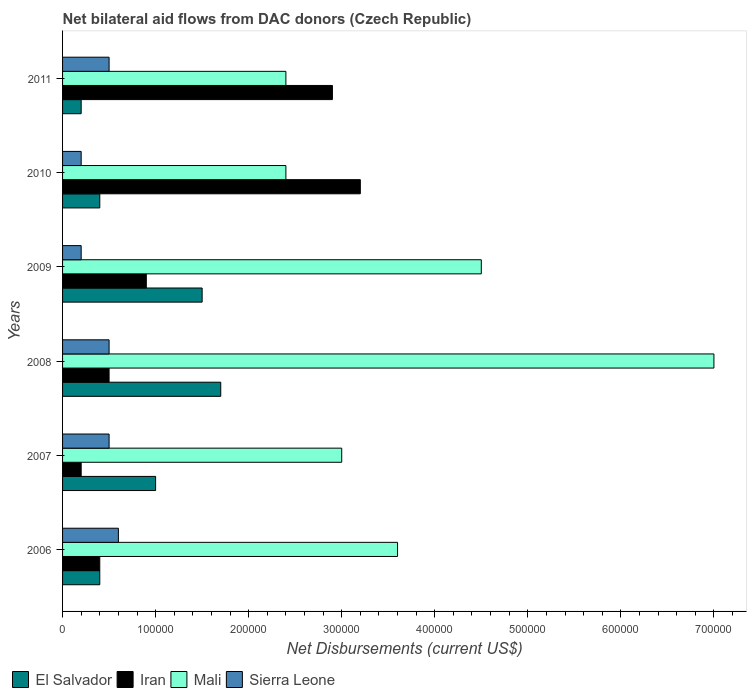How many different coloured bars are there?
Your answer should be compact. 4. How many groups of bars are there?
Offer a very short reply. 6. Are the number of bars on each tick of the Y-axis equal?
Keep it short and to the point. Yes. How many bars are there on the 4th tick from the bottom?
Make the answer very short. 4. What is the net bilateral aid flows in Iran in 2008?
Offer a terse response. 5.00e+04. Across all years, what is the maximum net bilateral aid flows in Mali?
Your response must be concise. 7.00e+05. Across all years, what is the minimum net bilateral aid flows in Iran?
Offer a terse response. 2.00e+04. In which year was the net bilateral aid flows in Iran minimum?
Ensure brevity in your answer.  2007. What is the total net bilateral aid flows in Sierra Leone in the graph?
Make the answer very short. 2.50e+05. What is the difference between the net bilateral aid flows in Sierra Leone in 2006 and that in 2007?
Ensure brevity in your answer.  10000. What is the difference between the net bilateral aid flows in El Salvador in 2006 and the net bilateral aid flows in Mali in 2008?
Make the answer very short. -6.60e+05. What is the average net bilateral aid flows in Mali per year?
Ensure brevity in your answer.  3.82e+05. In the year 2011, what is the difference between the net bilateral aid flows in El Salvador and net bilateral aid flows in Mali?
Give a very brief answer. -2.20e+05. In how many years, is the net bilateral aid flows in Sierra Leone greater than 540000 US$?
Your response must be concise. 0. What is the ratio of the net bilateral aid flows in Iran in 2010 to that in 2011?
Your response must be concise. 1.1. Is the net bilateral aid flows in Sierra Leone in 2006 less than that in 2011?
Keep it short and to the point. No. Is the difference between the net bilateral aid flows in El Salvador in 2006 and 2009 greater than the difference between the net bilateral aid flows in Mali in 2006 and 2009?
Your response must be concise. No. Is the sum of the net bilateral aid flows in El Salvador in 2009 and 2011 greater than the maximum net bilateral aid flows in Mali across all years?
Give a very brief answer. No. What does the 3rd bar from the top in 2009 represents?
Ensure brevity in your answer.  Iran. What does the 3rd bar from the bottom in 2011 represents?
Your answer should be very brief. Mali. How many years are there in the graph?
Your answer should be very brief. 6. What is the difference between two consecutive major ticks on the X-axis?
Offer a very short reply. 1.00e+05. Are the values on the major ticks of X-axis written in scientific E-notation?
Provide a short and direct response. No. Where does the legend appear in the graph?
Make the answer very short. Bottom left. How many legend labels are there?
Your response must be concise. 4. What is the title of the graph?
Ensure brevity in your answer.  Net bilateral aid flows from DAC donors (Czech Republic). What is the label or title of the X-axis?
Offer a terse response. Net Disbursements (current US$). What is the label or title of the Y-axis?
Your response must be concise. Years. What is the Net Disbursements (current US$) in El Salvador in 2007?
Offer a terse response. 1.00e+05. What is the Net Disbursements (current US$) of Iran in 2007?
Provide a succinct answer. 2.00e+04. What is the Net Disbursements (current US$) of Mali in 2007?
Your answer should be compact. 3.00e+05. What is the Net Disbursements (current US$) in Sierra Leone in 2007?
Your answer should be compact. 5.00e+04. What is the Net Disbursements (current US$) in Mali in 2008?
Offer a very short reply. 7.00e+05. What is the Net Disbursements (current US$) of Sierra Leone in 2008?
Make the answer very short. 5.00e+04. What is the Net Disbursements (current US$) of Iran in 2009?
Make the answer very short. 9.00e+04. What is the Net Disbursements (current US$) in Sierra Leone in 2009?
Provide a succinct answer. 2.00e+04. What is the Net Disbursements (current US$) of Mali in 2010?
Offer a terse response. 2.40e+05. What is the Net Disbursements (current US$) of Sierra Leone in 2010?
Provide a short and direct response. 2.00e+04. What is the Net Disbursements (current US$) in Mali in 2011?
Offer a terse response. 2.40e+05. Across all years, what is the maximum Net Disbursements (current US$) in El Salvador?
Ensure brevity in your answer.  1.70e+05. Across all years, what is the maximum Net Disbursements (current US$) in Iran?
Your answer should be very brief. 3.20e+05. Across all years, what is the maximum Net Disbursements (current US$) in Mali?
Keep it short and to the point. 7.00e+05. Across all years, what is the minimum Net Disbursements (current US$) of Iran?
Provide a succinct answer. 2.00e+04. Across all years, what is the minimum Net Disbursements (current US$) of Mali?
Offer a terse response. 2.40e+05. What is the total Net Disbursements (current US$) in El Salvador in the graph?
Offer a very short reply. 5.20e+05. What is the total Net Disbursements (current US$) of Iran in the graph?
Provide a short and direct response. 8.10e+05. What is the total Net Disbursements (current US$) in Mali in the graph?
Your answer should be compact. 2.29e+06. What is the total Net Disbursements (current US$) in Sierra Leone in the graph?
Keep it short and to the point. 2.50e+05. What is the difference between the Net Disbursements (current US$) in El Salvador in 2006 and that in 2007?
Make the answer very short. -6.00e+04. What is the difference between the Net Disbursements (current US$) of Iran in 2006 and that in 2007?
Your answer should be compact. 2.00e+04. What is the difference between the Net Disbursements (current US$) in El Salvador in 2006 and that in 2008?
Your answer should be compact. -1.30e+05. What is the difference between the Net Disbursements (current US$) of Iran in 2006 and that in 2008?
Make the answer very short. -10000. What is the difference between the Net Disbursements (current US$) in Mali in 2006 and that in 2009?
Give a very brief answer. -9.00e+04. What is the difference between the Net Disbursements (current US$) in Sierra Leone in 2006 and that in 2009?
Your answer should be very brief. 4.00e+04. What is the difference between the Net Disbursements (current US$) in El Salvador in 2006 and that in 2010?
Your response must be concise. 0. What is the difference between the Net Disbursements (current US$) in Iran in 2006 and that in 2010?
Your answer should be compact. -2.80e+05. What is the difference between the Net Disbursements (current US$) of Sierra Leone in 2006 and that in 2010?
Provide a succinct answer. 4.00e+04. What is the difference between the Net Disbursements (current US$) in Sierra Leone in 2006 and that in 2011?
Your answer should be compact. 10000. What is the difference between the Net Disbursements (current US$) of Iran in 2007 and that in 2008?
Ensure brevity in your answer.  -3.00e+04. What is the difference between the Net Disbursements (current US$) in Mali in 2007 and that in 2008?
Your answer should be compact. -4.00e+05. What is the difference between the Net Disbursements (current US$) of Iran in 2007 and that in 2009?
Keep it short and to the point. -7.00e+04. What is the difference between the Net Disbursements (current US$) of Mali in 2007 and that in 2011?
Your response must be concise. 6.00e+04. What is the difference between the Net Disbursements (current US$) in El Salvador in 2008 and that in 2009?
Provide a succinct answer. 2.00e+04. What is the difference between the Net Disbursements (current US$) in Iran in 2008 and that in 2009?
Your answer should be compact. -4.00e+04. What is the difference between the Net Disbursements (current US$) of Mali in 2008 and that in 2009?
Provide a short and direct response. 2.50e+05. What is the difference between the Net Disbursements (current US$) in El Salvador in 2008 and that in 2010?
Your response must be concise. 1.30e+05. What is the difference between the Net Disbursements (current US$) of Sierra Leone in 2008 and that in 2010?
Ensure brevity in your answer.  3.00e+04. What is the difference between the Net Disbursements (current US$) in Mali in 2008 and that in 2011?
Make the answer very short. 4.60e+05. What is the difference between the Net Disbursements (current US$) of Mali in 2009 and that in 2010?
Ensure brevity in your answer.  2.10e+05. What is the difference between the Net Disbursements (current US$) of Sierra Leone in 2009 and that in 2010?
Ensure brevity in your answer.  0. What is the difference between the Net Disbursements (current US$) in El Salvador in 2009 and that in 2011?
Provide a succinct answer. 1.30e+05. What is the difference between the Net Disbursements (current US$) of Iran in 2009 and that in 2011?
Ensure brevity in your answer.  -2.00e+05. What is the difference between the Net Disbursements (current US$) in El Salvador in 2010 and that in 2011?
Provide a succinct answer. 2.00e+04. What is the difference between the Net Disbursements (current US$) in Mali in 2010 and that in 2011?
Provide a short and direct response. 0. What is the difference between the Net Disbursements (current US$) in El Salvador in 2006 and the Net Disbursements (current US$) in Iran in 2007?
Your answer should be compact. 2.00e+04. What is the difference between the Net Disbursements (current US$) in Iran in 2006 and the Net Disbursements (current US$) in Mali in 2007?
Offer a terse response. -2.60e+05. What is the difference between the Net Disbursements (current US$) of Iran in 2006 and the Net Disbursements (current US$) of Sierra Leone in 2007?
Keep it short and to the point. -10000. What is the difference between the Net Disbursements (current US$) in El Salvador in 2006 and the Net Disbursements (current US$) in Mali in 2008?
Provide a succinct answer. -6.60e+05. What is the difference between the Net Disbursements (current US$) of El Salvador in 2006 and the Net Disbursements (current US$) of Sierra Leone in 2008?
Offer a very short reply. -10000. What is the difference between the Net Disbursements (current US$) of Iran in 2006 and the Net Disbursements (current US$) of Mali in 2008?
Keep it short and to the point. -6.60e+05. What is the difference between the Net Disbursements (current US$) of El Salvador in 2006 and the Net Disbursements (current US$) of Iran in 2009?
Provide a short and direct response. -5.00e+04. What is the difference between the Net Disbursements (current US$) of El Salvador in 2006 and the Net Disbursements (current US$) of Mali in 2009?
Provide a short and direct response. -4.10e+05. What is the difference between the Net Disbursements (current US$) in El Salvador in 2006 and the Net Disbursements (current US$) in Sierra Leone in 2009?
Your response must be concise. 2.00e+04. What is the difference between the Net Disbursements (current US$) in Iran in 2006 and the Net Disbursements (current US$) in Mali in 2009?
Provide a short and direct response. -4.10e+05. What is the difference between the Net Disbursements (current US$) of Mali in 2006 and the Net Disbursements (current US$) of Sierra Leone in 2009?
Your response must be concise. 3.40e+05. What is the difference between the Net Disbursements (current US$) in El Salvador in 2006 and the Net Disbursements (current US$) in Iran in 2010?
Ensure brevity in your answer.  -2.80e+05. What is the difference between the Net Disbursements (current US$) of El Salvador in 2006 and the Net Disbursements (current US$) of Sierra Leone in 2010?
Your response must be concise. 2.00e+04. What is the difference between the Net Disbursements (current US$) of Iran in 2006 and the Net Disbursements (current US$) of Sierra Leone in 2010?
Ensure brevity in your answer.  2.00e+04. What is the difference between the Net Disbursements (current US$) of El Salvador in 2006 and the Net Disbursements (current US$) of Mali in 2011?
Keep it short and to the point. -2.00e+05. What is the difference between the Net Disbursements (current US$) of Iran in 2006 and the Net Disbursements (current US$) of Mali in 2011?
Ensure brevity in your answer.  -2.00e+05. What is the difference between the Net Disbursements (current US$) in Iran in 2006 and the Net Disbursements (current US$) in Sierra Leone in 2011?
Ensure brevity in your answer.  -10000. What is the difference between the Net Disbursements (current US$) in Mali in 2006 and the Net Disbursements (current US$) in Sierra Leone in 2011?
Your response must be concise. 3.10e+05. What is the difference between the Net Disbursements (current US$) of El Salvador in 2007 and the Net Disbursements (current US$) of Mali in 2008?
Provide a short and direct response. -6.00e+05. What is the difference between the Net Disbursements (current US$) of Iran in 2007 and the Net Disbursements (current US$) of Mali in 2008?
Make the answer very short. -6.80e+05. What is the difference between the Net Disbursements (current US$) of Mali in 2007 and the Net Disbursements (current US$) of Sierra Leone in 2008?
Your response must be concise. 2.50e+05. What is the difference between the Net Disbursements (current US$) in El Salvador in 2007 and the Net Disbursements (current US$) in Iran in 2009?
Your answer should be very brief. 10000. What is the difference between the Net Disbursements (current US$) in El Salvador in 2007 and the Net Disbursements (current US$) in Mali in 2009?
Give a very brief answer. -3.50e+05. What is the difference between the Net Disbursements (current US$) in El Salvador in 2007 and the Net Disbursements (current US$) in Sierra Leone in 2009?
Your answer should be compact. 8.00e+04. What is the difference between the Net Disbursements (current US$) of Iran in 2007 and the Net Disbursements (current US$) of Mali in 2009?
Your answer should be compact. -4.30e+05. What is the difference between the Net Disbursements (current US$) of Mali in 2007 and the Net Disbursements (current US$) of Sierra Leone in 2009?
Provide a short and direct response. 2.80e+05. What is the difference between the Net Disbursements (current US$) of El Salvador in 2007 and the Net Disbursements (current US$) of Iran in 2011?
Offer a very short reply. -1.90e+05. What is the difference between the Net Disbursements (current US$) of El Salvador in 2007 and the Net Disbursements (current US$) of Mali in 2011?
Provide a short and direct response. -1.40e+05. What is the difference between the Net Disbursements (current US$) in Iran in 2007 and the Net Disbursements (current US$) in Mali in 2011?
Offer a terse response. -2.20e+05. What is the difference between the Net Disbursements (current US$) in Iran in 2007 and the Net Disbursements (current US$) in Sierra Leone in 2011?
Offer a very short reply. -3.00e+04. What is the difference between the Net Disbursements (current US$) in Mali in 2007 and the Net Disbursements (current US$) in Sierra Leone in 2011?
Give a very brief answer. 2.50e+05. What is the difference between the Net Disbursements (current US$) of El Salvador in 2008 and the Net Disbursements (current US$) of Mali in 2009?
Keep it short and to the point. -2.80e+05. What is the difference between the Net Disbursements (current US$) in Iran in 2008 and the Net Disbursements (current US$) in Mali in 2009?
Make the answer very short. -4.00e+05. What is the difference between the Net Disbursements (current US$) in Mali in 2008 and the Net Disbursements (current US$) in Sierra Leone in 2009?
Offer a very short reply. 6.80e+05. What is the difference between the Net Disbursements (current US$) in El Salvador in 2008 and the Net Disbursements (current US$) in Iran in 2010?
Offer a terse response. -1.50e+05. What is the difference between the Net Disbursements (current US$) of El Salvador in 2008 and the Net Disbursements (current US$) of Sierra Leone in 2010?
Your response must be concise. 1.50e+05. What is the difference between the Net Disbursements (current US$) in Iran in 2008 and the Net Disbursements (current US$) in Mali in 2010?
Your answer should be compact. -1.90e+05. What is the difference between the Net Disbursements (current US$) of Iran in 2008 and the Net Disbursements (current US$) of Sierra Leone in 2010?
Give a very brief answer. 3.00e+04. What is the difference between the Net Disbursements (current US$) of Mali in 2008 and the Net Disbursements (current US$) of Sierra Leone in 2010?
Your answer should be very brief. 6.80e+05. What is the difference between the Net Disbursements (current US$) of El Salvador in 2008 and the Net Disbursements (current US$) of Mali in 2011?
Ensure brevity in your answer.  -7.00e+04. What is the difference between the Net Disbursements (current US$) in El Salvador in 2008 and the Net Disbursements (current US$) in Sierra Leone in 2011?
Ensure brevity in your answer.  1.20e+05. What is the difference between the Net Disbursements (current US$) of Mali in 2008 and the Net Disbursements (current US$) of Sierra Leone in 2011?
Offer a terse response. 6.50e+05. What is the difference between the Net Disbursements (current US$) in El Salvador in 2009 and the Net Disbursements (current US$) in Iran in 2010?
Give a very brief answer. -1.70e+05. What is the difference between the Net Disbursements (current US$) in El Salvador in 2009 and the Net Disbursements (current US$) in Sierra Leone in 2010?
Your response must be concise. 1.30e+05. What is the difference between the Net Disbursements (current US$) of El Salvador in 2009 and the Net Disbursements (current US$) of Mali in 2011?
Provide a short and direct response. -9.00e+04. What is the difference between the Net Disbursements (current US$) in El Salvador in 2010 and the Net Disbursements (current US$) in Iran in 2011?
Offer a very short reply. -2.50e+05. What is the difference between the Net Disbursements (current US$) of El Salvador in 2010 and the Net Disbursements (current US$) of Mali in 2011?
Give a very brief answer. -2.00e+05. What is the difference between the Net Disbursements (current US$) of Mali in 2010 and the Net Disbursements (current US$) of Sierra Leone in 2011?
Ensure brevity in your answer.  1.90e+05. What is the average Net Disbursements (current US$) of El Salvador per year?
Make the answer very short. 8.67e+04. What is the average Net Disbursements (current US$) in Iran per year?
Your answer should be very brief. 1.35e+05. What is the average Net Disbursements (current US$) in Mali per year?
Your response must be concise. 3.82e+05. What is the average Net Disbursements (current US$) of Sierra Leone per year?
Your response must be concise. 4.17e+04. In the year 2006, what is the difference between the Net Disbursements (current US$) in El Salvador and Net Disbursements (current US$) in Mali?
Provide a succinct answer. -3.20e+05. In the year 2006, what is the difference between the Net Disbursements (current US$) of Iran and Net Disbursements (current US$) of Mali?
Your response must be concise. -3.20e+05. In the year 2006, what is the difference between the Net Disbursements (current US$) of Mali and Net Disbursements (current US$) of Sierra Leone?
Ensure brevity in your answer.  3.00e+05. In the year 2007, what is the difference between the Net Disbursements (current US$) of El Salvador and Net Disbursements (current US$) of Sierra Leone?
Offer a terse response. 5.00e+04. In the year 2007, what is the difference between the Net Disbursements (current US$) of Iran and Net Disbursements (current US$) of Mali?
Your response must be concise. -2.80e+05. In the year 2007, what is the difference between the Net Disbursements (current US$) of Iran and Net Disbursements (current US$) of Sierra Leone?
Give a very brief answer. -3.00e+04. In the year 2007, what is the difference between the Net Disbursements (current US$) in Mali and Net Disbursements (current US$) in Sierra Leone?
Your response must be concise. 2.50e+05. In the year 2008, what is the difference between the Net Disbursements (current US$) of El Salvador and Net Disbursements (current US$) of Iran?
Offer a very short reply. 1.20e+05. In the year 2008, what is the difference between the Net Disbursements (current US$) in El Salvador and Net Disbursements (current US$) in Mali?
Provide a short and direct response. -5.30e+05. In the year 2008, what is the difference between the Net Disbursements (current US$) in Iran and Net Disbursements (current US$) in Mali?
Provide a short and direct response. -6.50e+05. In the year 2008, what is the difference between the Net Disbursements (current US$) of Iran and Net Disbursements (current US$) of Sierra Leone?
Keep it short and to the point. 0. In the year 2008, what is the difference between the Net Disbursements (current US$) in Mali and Net Disbursements (current US$) in Sierra Leone?
Offer a terse response. 6.50e+05. In the year 2009, what is the difference between the Net Disbursements (current US$) of El Salvador and Net Disbursements (current US$) of Iran?
Give a very brief answer. 6.00e+04. In the year 2009, what is the difference between the Net Disbursements (current US$) of El Salvador and Net Disbursements (current US$) of Mali?
Your answer should be compact. -3.00e+05. In the year 2009, what is the difference between the Net Disbursements (current US$) in Iran and Net Disbursements (current US$) in Mali?
Provide a succinct answer. -3.60e+05. In the year 2010, what is the difference between the Net Disbursements (current US$) of El Salvador and Net Disbursements (current US$) of Iran?
Provide a short and direct response. -2.80e+05. In the year 2010, what is the difference between the Net Disbursements (current US$) of El Salvador and Net Disbursements (current US$) of Mali?
Give a very brief answer. -2.00e+05. In the year 2010, what is the difference between the Net Disbursements (current US$) in El Salvador and Net Disbursements (current US$) in Sierra Leone?
Your response must be concise. 2.00e+04. In the year 2010, what is the difference between the Net Disbursements (current US$) of Iran and Net Disbursements (current US$) of Mali?
Keep it short and to the point. 8.00e+04. In the year 2010, what is the difference between the Net Disbursements (current US$) in Iran and Net Disbursements (current US$) in Sierra Leone?
Your response must be concise. 3.00e+05. In the year 2011, what is the difference between the Net Disbursements (current US$) of El Salvador and Net Disbursements (current US$) of Iran?
Provide a succinct answer. -2.70e+05. In the year 2011, what is the difference between the Net Disbursements (current US$) in El Salvador and Net Disbursements (current US$) in Mali?
Ensure brevity in your answer.  -2.20e+05. In the year 2011, what is the difference between the Net Disbursements (current US$) in El Salvador and Net Disbursements (current US$) in Sierra Leone?
Your answer should be compact. -3.00e+04. In the year 2011, what is the difference between the Net Disbursements (current US$) of Mali and Net Disbursements (current US$) of Sierra Leone?
Provide a succinct answer. 1.90e+05. What is the ratio of the Net Disbursements (current US$) in Sierra Leone in 2006 to that in 2007?
Make the answer very short. 1.2. What is the ratio of the Net Disbursements (current US$) in El Salvador in 2006 to that in 2008?
Ensure brevity in your answer.  0.24. What is the ratio of the Net Disbursements (current US$) in Iran in 2006 to that in 2008?
Your answer should be compact. 0.8. What is the ratio of the Net Disbursements (current US$) in Mali in 2006 to that in 2008?
Provide a succinct answer. 0.51. What is the ratio of the Net Disbursements (current US$) in Sierra Leone in 2006 to that in 2008?
Your response must be concise. 1.2. What is the ratio of the Net Disbursements (current US$) in El Salvador in 2006 to that in 2009?
Provide a short and direct response. 0.27. What is the ratio of the Net Disbursements (current US$) of Iran in 2006 to that in 2009?
Make the answer very short. 0.44. What is the ratio of the Net Disbursements (current US$) in El Salvador in 2006 to that in 2010?
Provide a short and direct response. 1. What is the ratio of the Net Disbursements (current US$) of Sierra Leone in 2006 to that in 2010?
Your answer should be compact. 3. What is the ratio of the Net Disbursements (current US$) in Iran in 2006 to that in 2011?
Ensure brevity in your answer.  0.14. What is the ratio of the Net Disbursements (current US$) in Mali in 2006 to that in 2011?
Provide a succinct answer. 1.5. What is the ratio of the Net Disbursements (current US$) in Sierra Leone in 2006 to that in 2011?
Make the answer very short. 1.2. What is the ratio of the Net Disbursements (current US$) in El Salvador in 2007 to that in 2008?
Your answer should be compact. 0.59. What is the ratio of the Net Disbursements (current US$) of Iran in 2007 to that in 2008?
Provide a short and direct response. 0.4. What is the ratio of the Net Disbursements (current US$) of Mali in 2007 to that in 2008?
Make the answer very short. 0.43. What is the ratio of the Net Disbursements (current US$) in Sierra Leone in 2007 to that in 2008?
Keep it short and to the point. 1. What is the ratio of the Net Disbursements (current US$) in Iran in 2007 to that in 2009?
Ensure brevity in your answer.  0.22. What is the ratio of the Net Disbursements (current US$) of Sierra Leone in 2007 to that in 2009?
Provide a succinct answer. 2.5. What is the ratio of the Net Disbursements (current US$) in Iran in 2007 to that in 2010?
Give a very brief answer. 0.06. What is the ratio of the Net Disbursements (current US$) in Mali in 2007 to that in 2010?
Your answer should be compact. 1.25. What is the ratio of the Net Disbursements (current US$) of Sierra Leone in 2007 to that in 2010?
Give a very brief answer. 2.5. What is the ratio of the Net Disbursements (current US$) of El Salvador in 2007 to that in 2011?
Keep it short and to the point. 5. What is the ratio of the Net Disbursements (current US$) in Iran in 2007 to that in 2011?
Provide a succinct answer. 0.07. What is the ratio of the Net Disbursements (current US$) in Mali in 2007 to that in 2011?
Give a very brief answer. 1.25. What is the ratio of the Net Disbursements (current US$) of El Salvador in 2008 to that in 2009?
Your answer should be compact. 1.13. What is the ratio of the Net Disbursements (current US$) in Iran in 2008 to that in 2009?
Offer a terse response. 0.56. What is the ratio of the Net Disbursements (current US$) of Mali in 2008 to that in 2009?
Your answer should be compact. 1.56. What is the ratio of the Net Disbursements (current US$) of Sierra Leone in 2008 to that in 2009?
Give a very brief answer. 2.5. What is the ratio of the Net Disbursements (current US$) of El Salvador in 2008 to that in 2010?
Offer a very short reply. 4.25. What is the ratio of the Net Disbursements (current US$) of Iran in 2008 to that in 2010?
Make the answer very short. 0.16. What is the ratio of the Net Disbursements (current US$) of Mali in 2008 to that in 2010?
Provide a succinct answer. 2.92. What is the ratio of the Net Disbursements (current US$) of El Salvador in 2008 to that in 2011?
Offer a terse response. 8.5. What is the ratio of the Net Disbursements (current US$) in Iran in 2008 to that in 2011?
Make the answer very short. 0.17. What is the ratio of the Net Disbursements (current US$) of Mali in 2008 to that in 2011?
Your response must be concise. 2.92. What is the ratio of the Net Disbursements (current US$) of Sierra Leone in 2008 to that in 2011?
Provide a short and direct response. 1. What is the ratio of the Net Disbursements (current US$) of El Salvador in 2009 to that in 2010?
Offer a terse response. 3.75. What is the ratio of the Net Disbursements (current US$) in Iran in 2009 to that in 2010?
Provide a short and direct response. 0.28. What is the ratio of the Net Disbursements (current US$) of Mali in 2009 to that in 2010?
Offer a terse response. 1.88. What is the ratio of the Net Disbursements (current US$) of Sierra Leone in 2009 to that in 2010?
Ensure brevity in your answer.  1. What is the ratio of the Net Disbursements (current US$) of El Salvador in 2009 to that in 2011?
Provide a short and direct response. 7.5. What is the ratio of the Net Disbursements (current US$) of Iran in 2009 to that in 2011?
Ensure brevity in your answer.  0.31. What is the ratio of the Net Disbursements (current US$) in Mali in 2009 to that in 2011?
Offer a very short reply. 1.88. What is the ratio of the Net Disbursements (current US$) in Sierra Leone in 2009 to that in 2011?
Ensure brevity in your answer.  0.4. What is the ratio of the Net Disbursements (current US$) in El Salvador in 2010 to that in 2011?
Keep it short and to the point. 2. What is the ratio of the Net Disbursements (current US$) in Iran in 2010 to that in 2011?
Offer a very short reply. 1.1. What is the ratio of the Net Disbursements (current US$) of Mali in 2010 to that in 2011?
Provide a short and direct response. 1. What is the difference between the highest and the second highest Net Disbursements (current US$) of Sierra Leone?
Offer a terse response. 10000. What is the difference between the highest and the lowest Net Disbursements (current US$) in Sierra Leone?
Give a very brief answer. 4.00e+04. 